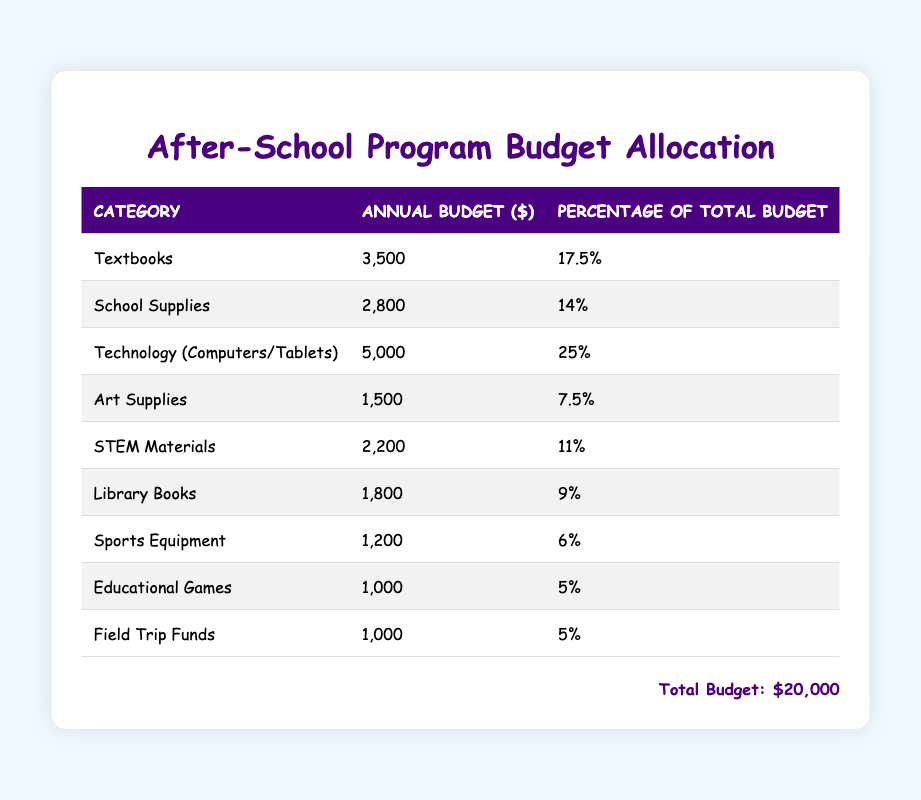What is the total budget for educational supplies and resources? The total budget is explicitly stated at the bottom of the table as $20,000.
Answer: $20,000 How much is allocated for Technology (Computers/Tablets)? The specific allocation for Technology (Computers/Tablets) is listed in the table under the "Annual Budget ($)" column, which shows $5,000.
Answer: $5,000 What percentage of the total budget is spent on textbooks? The percentage allocated for textbooks is shown in the table. It indicates a budget of 17.5%.
Answer: 17.5% Is the budget for Library Books greater than that for Sports Equipment? The budget for Library Books is $1,800, while Sports Equipment has a budget of $1,200. Since $1,800 is greater than $1,200, the answer is true.
Answer: Yes What is the combined budget for Art Supplies and Educational Games? The budget for Art Supplies is $1,500 and for Educational Games is $1,000. Combining these amounts gives $1,500 + $1,000 = $2,500.
Answer: $2,500 How much more is allocated for Technology compared to Sports Equipment? The budget for Technology is $5,000 and for Sports Equipment is $1,200. The difference is calculated as $5,000 - $1,200 = $3,800.
Answer: $3,800 What is the average budget allocation for the categories listed in the table? To find the average, we sum all the budget allocations: 3500 + 2800 + 5000 + 1500 + 2200 + 1800 + 1200 + 1000 + 1000 = 20000. There are 9 categories, so the average is $20,000 / 9 = approximately $2,222.22.
Answer: Approximately $2,222.22 Which category has the smallest budget, and what is it? By reviewing the budget amounts, Sports Equipment and Educational Games both have the lowest budget at $1,200 and $1,000 respectively. Thus, Educational Games, at $1,000, is the smallest.
Answer: Educational Games, $1,000 What percentage of the total budget is used for STEM Materials compared to Textbooks? The percentage for STEM Materials is 11%, and for Textbooks, it is 17.5%. To compare, the math shows that 11% is less than 17.5%, confirming STEM Materials makes up a smaller percentage.
Answer: STEM Materials is lesser 